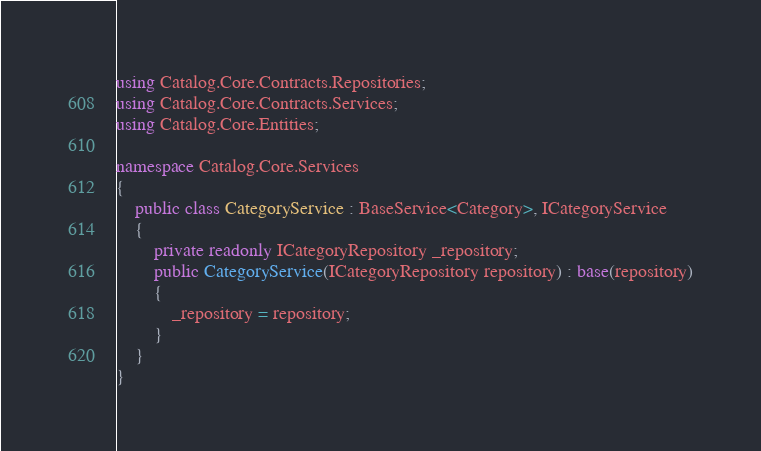Convert code to text. <code><loc_0><loc_0><loc_500><loc_500><_C#_>using Catalog.Core.Contracts.Repositories;
using Catalog.Core.Contracts.Services;
using Catalog.Core.Entities;

namespace Catalog.Core.Services
{
    public class CategoryService : BaseService<Category>, ICategoryService
    {
        private readonly ICategoryRepository _repository;
        public CategoryService(ICategoryRepository repository) : base(repository)
        {
            _repository = repository;
        }
    }
}</code> 